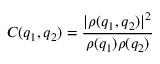Convert formula to latex. <formula><loc_0><loc_0><loc_500><loc_500>C ( q _ { 1 } , q _ { 2 } ) = \frac { | \rho ( q _ { 1 } , q _ { 2 } ) | ^ { 2 } } { \rho ( q _ { 1 } ) \rho ( q _ { 2 } ) }</formula> 